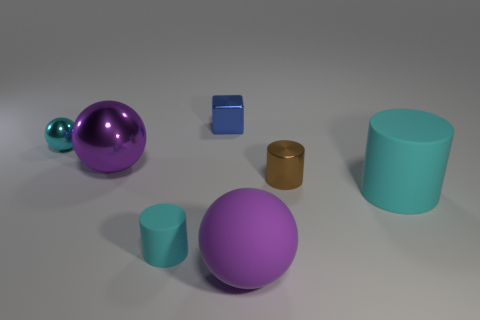How many objects are small metal spheres or large spheres that are behind the large rubber cylinder?
Your response must be concise. 2. Does the cyan cylinder that is to the left of the metal cube have the same material as the big cylinder?
Ensure brevity in your answer.  Yes. There is a matte thing that is the same size as the blue metallic thing; what is its color?
Your answer should be compact. Cyan. Is there another small cyan object of the same shape as the tiny cyan shiny thing?
Keep it short and to the point. No. What color is the thing behind the cyan object behind the large thing that is left of the large matte sphere?
Give a very brief answer. Blue. What number of shiny objects are either purple blocks or tiny brown cylinders?
Keep it short and to the point. 1. Is the number of cyan matte objects that are left of the tiny shiny cylinder greater than the number of small cyan matte cylinders that are right of the big metal sphere?
Ensure brevity in your answer.  No. How many other objects are there of the same size as the rubber ball?
Offer a very short reply. 2. What is the size of the cyan sphere left of the matte thing that is on the left side of the blue cube?
Your answer should be compact. Small. What number of large things are either blue objects or purple balls?
Ensure brevity in your answer.  2. 